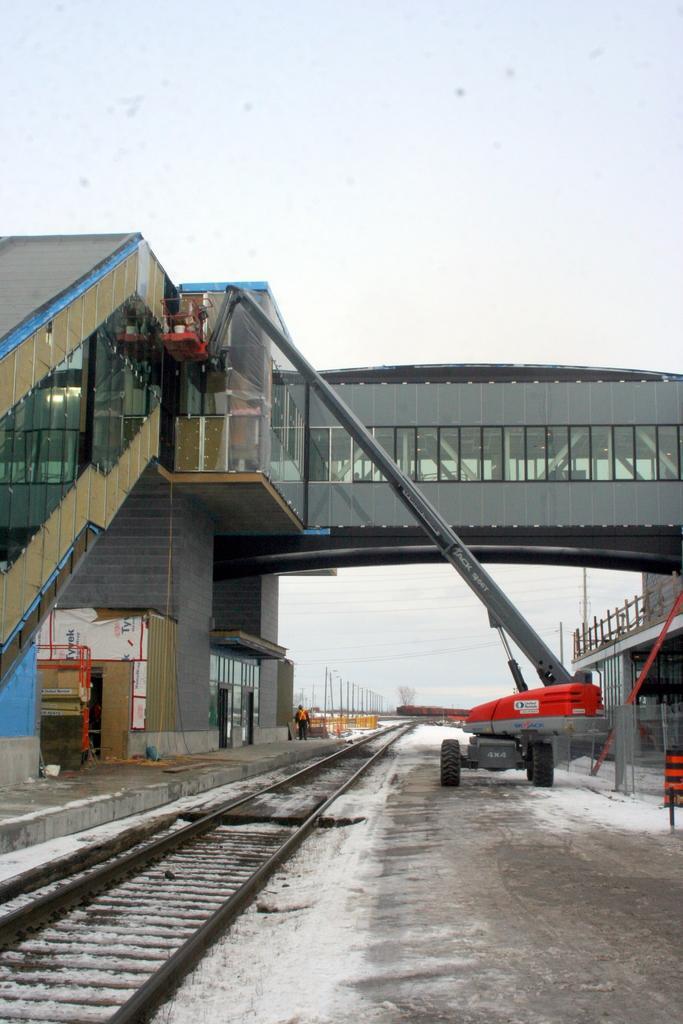How would you summarize this image in a sentence or two? In this image I can see the track. To the side of the track there is a vehicle and I can see the bridge which is in grey color. In the back I can see the white sky. 